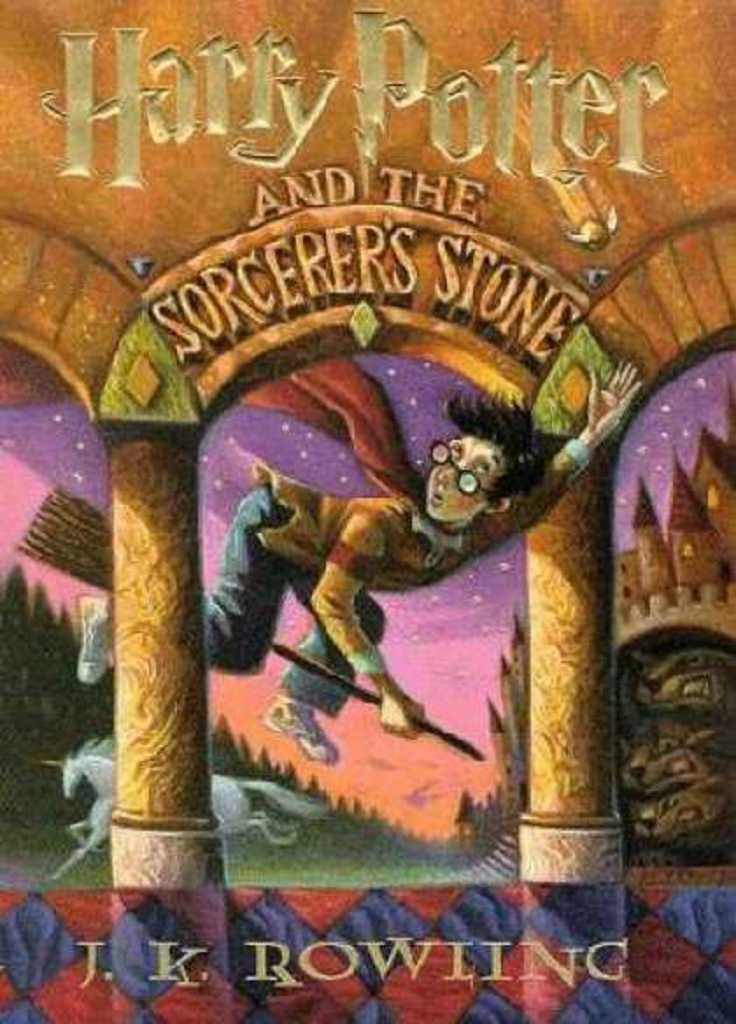<image>
Provide a brief description of the given image. Cover of a Harry Potter book with a boy riding a broomstick on the cover. 